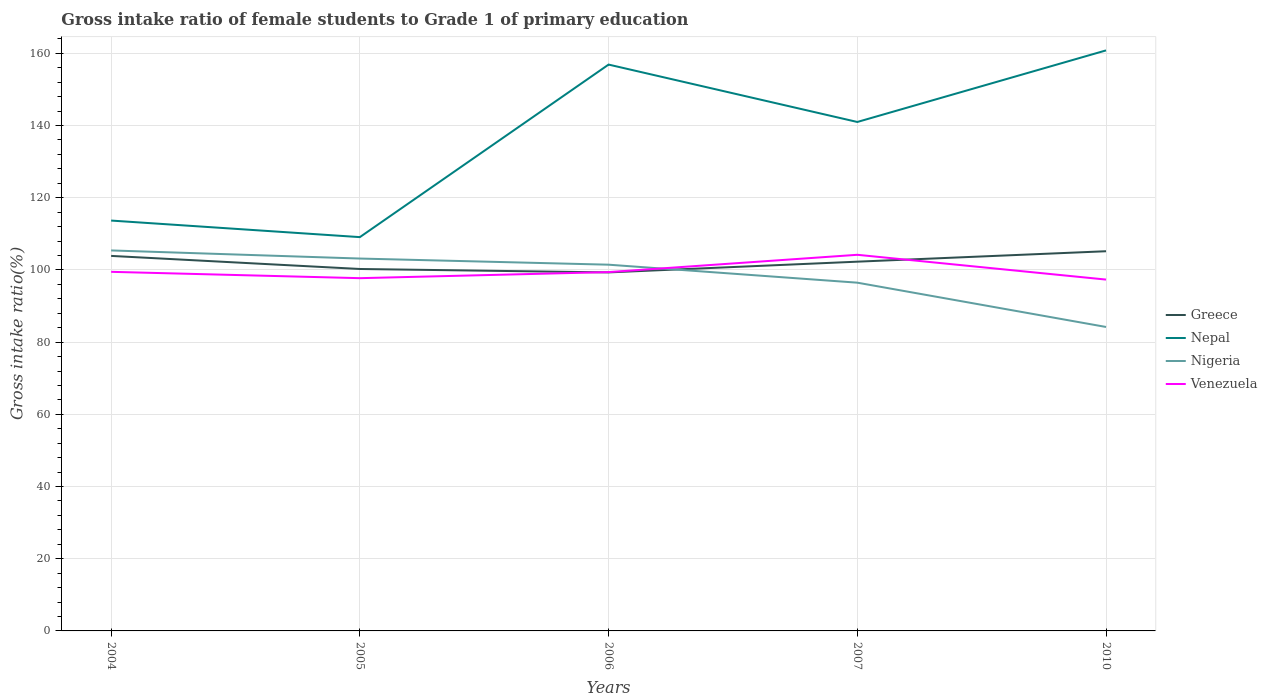Across all years, what is the maximum gross intake ratio in Nigeria?
Ensure brevity in your answer.  84.2. In which year was the gross intake ratio in Nepal maximum?
Give a very brief answer. 2005. What is the total gross intake ratio in Greece in the graph?
Keep it short and to the point. -5.87. What is the difference between the highest and the second highest gross intake ratio in Nigeria?
Your answer should be very brief. 21.2. What is the difference between the highest and the lowest gross intake ratio in Venezuela?
Your answer should be compact. 1. Is the gross intake ratio in Nepal strictly greater than the gross intake ratio in Venezuela over the years?
Provide a succinct answer. No. Does the graph contain grids?
Your answer should be very brief. Yes. How many legend labels are there?
Offer a terse response. 4. What is the title of the graph?
Keep it short and to the point. Gross intake ratio of female students to Grade 1 of primary education. Does "Kiribati" appear as one of the legend labels in the graph?
Ensure brevity in your answer.  No. What is the label or title of the X-axis?
Provide a short and direct response. Years. What is the label or title of the Y-axis?
Your response must be concise. Gross intake ratio(%). What is the Gross intake ratio(%) in Greece in 2004?
Provide a short and direct response. 103.89. What is the Gross intake ratio(%) of Nepal in 2004?
Your response must be concise. 113.68. What is the Gross intake ratio(%) in Nigeria in 2004?
Offer a terse response. 105.4. What is the Gross intake ratio(%) of Venezuela in 2004?
Your answer should be compact. 99.47. What is the Gross intake ratio(%) of Greece in 2005?
Ensure brevity in your answer.  100.26. What is the Gross intake ratio(%) in Nepal in 2005?
Provide a succinct answer. 109.09. What is the Gross intake ratio(%) of Nigeria in 2005?
Your response must be concise. 103.15. What is the Gross intake ratio(%) in Venezuela in 2005?
Keep it short and to the point. 97.72. What is the Gross intake ratio(%) of Greece in 2006?
Provide a succinct answer. 99.31. What is the Gross intake ratio(%) of Nepal in 2006?
Provide a succinct answer. 156.88. What is the Gross intake ratio(%) in Nigeria in 2006?
Offer a very short reply. 101.45. What is the Gross intake ratio(%) of Venezuela in 2006?
Ensure brevity in your answer.  99.4. What is the Gross intake ratio(%) of Greece in 2007?
Your response must be concise. 102.29. What is the Gross intake ratio(%) of Nepal in 2007?
Keep it short and to the point. 140.98. What is the Gross intake ratio(%) of Nigeria in 2007?
Offer a terse response. 96.47. What is the Gross intake ratio(%) in Venezuela in 2007?
Give a very brief answer. 104.19. What is the Gross intake ratio(%) of Greece in 2010?
Provide a short and direct response. 105.18. What is the Gross intake ratio(%) of Nepal in 2010?
Your answer should be very brief. 160.81. What is the Gross intake ratio(%) of Nigeria in 2010?
Offer a very short reply. 84.2. What is the Gross intake ratio(%) of Venezuela in 2010?
Offer a terse response. 97.33. Across all years, what is the maximum Gross intake ratio(%) of Greece?
Your answer should be very brief. 105.18. Across all years, what is the maximum Gross intake ratio(%) of Nepal?
Your answer should be compact. 160.81. Across all years, what is the maximum Gross intake ratio(%) of Nigeria?
Ensure brevity in your answer.  105.4. Across all years, what is the maximum Gross intake ratio(%) of Venezuela?
Your answer should be very brief. 104.19. Across all years, what is the minimum Gross intake ratio(%) of Greece?
Your response must be concise. 99.31. Across all years, what is the minimum Gross intake ratio(%) of Nepal?
Your answer should be very brief. 109.09. Across all years, what is the minimum Gross intake ratio(%) in Nigeria?
Offer a very short reply. 84.2. Across all years, what is the minimum Gross intake ratio(%) in Venezuela?
Your response must be concise. 97.33. What is the total Gross intake ratio(%) in Greece in the graph?
Your answer should be very brief. 510.92. What is the total Gross intake ratio(%) in Nepal in the graph?
Provide a short and direct response. 681.44. What is the total Gross intake ratio(%) in Nigeria in the graph?
Provide a short and direct response. 490.67. What is the total Gross intake ratio(%) in Venezuela in the graph?
Your answer should be very brief. 498.11. What is the difference between the Gross intake ratio(%) in Greece in 2004 and that in 2005?
Offer a terse response. 3.62. What is the difference between the Gross intake ratio(%) in Nepal in 2004 and that in 2005?
Your response must be concise. 4.59. What is the difference between the Gross intake ratio(%) of Nigeria in 2004 and that in 2005?
Keep it short and to the point. 2.25. What is the difference between the Gross intake ratio(%) in Venezuela in 2004 and that in 2005?
Your response must be concise. 1.76. What is the difference between the Gross intake ratio(%) in Greece in 2004 and that in 2006?
Give a very brief answer. 4.57. What is the difference between the Gross intake ratio(%) in Nepal in 2004 and that in 2006?
Make the answer very short. -43.21. What is the difference between the Gross intake ratio(%) of Nigeria in 2004 and that in 2006?
Ensure brevity in your answer.  3.94. What is the difference between the Gross intake ratio(%) in Venezuela in 2004 and that in 2006?
Your answer should be very brief. 0.07. What is the difference between the Gross intake ratio(%) in Greece in 2004 and that in 2007?
Your response must be concise. 1.6. What is the difference between the Gross intake ratio(%) of Nepal in 2004 and that in 2007?
Your answer should be compact. -27.31. What is the difference between the Gross intake ratio(%) of Nigeria in 2004 and that in 2007?
Your answer should be compact. 8.93. What is the difference between the Gross intake ratio(%) in Venezuela in 2004 and that in 2007?
Offer a very short reply. -4.72. What is the difference between the Gross intake ratio(%) in Greece in 2004 and that in 2010?
Keep it short and to the point. -1.29. What is the difference between the Gross intake ratio(%) in Nepal in 2004 and that in 2010?
Make the answer very short. -47.14. What is the difference between the Gross intake ratio(%) of Nigeria in 2004 and that in 2010?
Make the answer very short. 21.2. What is the difference between the Gross intake ratio(%) in Venezuela in 2004 and that in 2010?
Provide a short and direct response. 2.15. What is the difference between the Gross intake ratio(%) of Greece in 2005 and that in 2006?
Your answer should be compact. 0.95. What is the difference between the Gross intake ratio(%) in Nepal in 2005 and that in 2006?
Provide a short and direct response. -47.8. What is the difference between the Gross intake ratio(%) of Nigeria in 2005 and that in 2006?
Keep it short and to the point. 1.7. What is the difference between the Gross intake ratio(%) in Venezuela in 2005 and that in 2006?
Provide a short and direct response. -1.68. What is the difference between the Gross intake ratio(%) of Greece in 2005 and that in 2007?
Make the answer very short. -2.03. What is the difference between the Gross intake ratio(%) in Nepal in 2005 and that in 2007?
Give a very brief answer. -31.89. What is the difference between the Gross intake ratio(%) of Nigeria in 2005 and that in 2007?
Give a very brief answer. 6.68. What is the difference between the Gross intake ratio(%) of Venezuela in 2005 and that in 2007?
Provide a short and direct response. -6.48. What is the difference between the Gross intake ratio(%) of Greece in 2005 and that in 2010?
Provide a succinct answer. -4.92. What is the difference between the Gross intake ratio(%) of Nepal in 2005 and that in 2010?
Your response must be concise. -51.72. What is the difference between the Gross intake ratio(%) in Nigeria in 2005 and that in 2010?
Provide a short and direct response. 18.95. What is the difference between the Gross intake ratio(%) of Venezuela in 2005 and that in 2010?
Your response must be concise. 0.39. What is the difference between the Gross intake ratio(%) of Greece in 2006 and that in 2007?
Provide a succinct answer. -2.98. What is the difference between the Gross intake ratio(%) in Nepal in 2006 and that in 2007?
Ensure brevity in your answer.  15.9. What is the difference between the Gross intake ratio(%) in Nigeria in 2006 and that in 2007?
Your response must be concise. 4.98. What is the difference between the Gross intake ratio(%) in Venezuela in 2006 and that in 2007?
Give a very brief answer. -4.79. What is the difference between the Gross intake ratio(%) in Greece in 2006 and that in 2010?
Give a very brief answer. -5.87. What is the difference between the Gross intake ratio(%) of Nepal in 2006 and that in 2010?
Provide a short and direct response. -3.93. What is the difference between the Gross intake ratio(%) of Nigeria in 2006 and that in 2010?
Your answer should be compact. 17.25. What is the difference between the Gross intake ratio(%) in Venezuela in 2006 and that in 2010?
Provide a short and direct response. 2.08. What is the difference between the Gross intake ratio(%) in Greece in 2007 and that in 2010?
Offer a terse response. -2.89. What is the difference between the Gross intake ratio(%) in Nepal in 2007 and that in 2010?
Keep it short and to the point. -19.83. What is the difference between the Gross intake ratio(%) of Nigeria in 2007 and that in 2010?
Provide a short and direct response. 12.27. What is the difference between the Gross intake ratio(%) of Venezuela in 2007 and that in 2010?
Offer a very short reply. 6.87. What is the difference between the Gross intake ratio(%) in Greece in 2004 and the Gross intake ratio(%) in Nepal in 2005?
Make the answer very short. -5.2. What is the difference between the Gross intake ratio(%) of Greece in 2004 and the Gross intake ratio(%) of Nigeria in 2005?
Give a very brief answer. 0.73. What is the difference between the Gross intake ratio(%) in Greece in 2004 and the Gross intake ratio(%) in Venezuela in 2005?
Ensure brevity in your answer.  6.17. What is the difference between the Gross intake ratio(%) of Nepal in 2004 and the Gross intake ratio(%) of Nigeria in 2005?
Provide a succinct answer. 10.52. What is the difference between the Gross intake ratio(%) of Nepal in 2004 and the Gross intake ratio(%) of Venezuela in 2005?
Your response must be concise. 15.96. What is the difference between the Gross intake ratio(%) in Nigeria in 2004 and the Gross intake ratio(%) in Venezuela in 2005?
Make the answer very short. 7.68. What is the difference between the Gross intake ratio(%) of Greece in 2004 and the Gross intake ratio(%) of Nepal in 2006?
Offer a very short reply. -53. What is the difference between the Gross intake ratio(%) in Greece in 2004 and the Gross intake ratio(%) in Nigeria in 2006?
Provide a short and direct response. 2.43. What is the difference between the Gross intake ratio(%) in Greece in 2004 and the Gross intake ratio(%) in Venezuela in 2006?
Offer a very short reply. 4.48. What is the difference between the Gross intake ratio(%) in Nepal in 2004 and the Gross intake ratio(%) in Nigeria in 2006?
Your response must be concise. 12.22. What is the difference between the Gross intake ratio(%) in Nepal in 2004 and the Gross intake ratio(%) in Venezuela in 2006?
Offer a terse response. 14.27. What is the difference between the Gross intake ratio(%) of Nigeria in 2004 and the Gross intake ratio(%) of Venezuela in 2006?
Offer a very short reply. 6. What is the difference between the Gross intake ratio(%) of Greece in 2004 and the Gross intake ratio(%) of Nepal in 2007?
Provide a short and direct response. -37.1. What is the difference between the Gross intake ratio(%) in Greece in 2004 and the Gross intake ratio(%) in Nigeria in 2007?
Keep it short and to the point. 7.42. What is the difference between the Gross intake ratio(%) of Greece in 2004 and the Gross intake ratio(%) of Venezuela in 2007?
Offer a very short reply. -0.31. What is the difference between the Gross intake ratio(%) in Nepal in 2004 and the Gross intake ratio(%) in Nigeria in 2007?
Provide a succinct answer. 17.21. What is the difference between the Gross intake ratio(%) in Nepal in 2004 and the Gross intake ratio(%) in Venezuela in 2007?
Ensure brevity in your answer.  9.48. What is the difference between the Gross intake ratio(%) of Nigeria in 2004 and the Gross intake ratio(%) of Venezuela in 2007?
Your response must be concise. 1.2. What is the difference between the Gross intake ratio(%) in Greece in 2004 and the Gross intake ratio(%) in Nepal in 2010?
Make the answer very short. -56.93. What is the difference between the Gross intake ratio(%) of Greece in 2004 and the Gross intake ratio(%) of Nigeria in 2010?
Your answer should be compact. 19.69. What is the difference between the Gross intake ratio(%) in Greece in 2004 and the Gross intake ratio(%) in Venezuela in 2010?
Provide a short and direct response. 6.56. What is the difference between the Gross intake ratio(%) in Nepal in 2004 and the Gross intake ratio(%) in Nigeria in 2010?
Provide a succinct answer. 29.48. What is the difference between the Gross intake ratio(%) of Nepal in 2004 and the Gross intake ratio(%) of Venezuela in 2010?
Keep it short and to the point. 16.35. What is the difference between the Gross intake ratio(%) of Nigeria in 2004 and the Gross intake ratio(%) of Venezuela in 2010?
Your answer should be compact. 8.07. What is the difference between the Gross intake ratio(%) in Greece in 2005 and the Gross intake ratio(%) in Nepal in 2006?
Your response must be concise. -56.62. What is the difference between the Gross intake ratio(%) in Greece in 2005 and the Gross intake ratio(%) in Nigeria in 2006?
Ensure brevity in your answer.  -1.19. What is the difference between the Gross intake ratio(%) in Greece in 2005 and the Gross intake ratio(%) in Venezuela in 2006?
Provide a succinct answer. 0.86. What is the difference between the Gross intake ratio(%) in Nepal in 2005 and the Gross intake ratio(%) in Nigeria in 2006?
Offer a terse response. 7.64. What is the difference between the Gross intake ratio(%) of Nepal in 2005 and the Gross intake ratio(%) of Venezuela in 2006?
Provide a short and direct response. 9.69. What is the difference between the Gross intake ratio(%) of Nigeria in 2005 and the Gross intake ratio(%) of Venezuela in 2006?
Make the answer very short. 3.75. What is the difference between the Gross intake ratio(%) of Greece in 2005 and the Gross intake ratio(%) of Nepal in 2007?
Keep it short and to the point. -40.72. What is the difference between the Gross intake ratio(%) of Greece in 2005 and the Gross intake ratio(%) of Nigeria in 2007?
Provide a succinct answer. 3.79. What is the difference between the Gross intake ratio(%) in Greece in 2005 and the Gross intake ratio(%) in Venezuela in 2007?
Your response must be concise. -3.93. What is the difference between the Gross intake ratio(%) of Nepal in 2005 and the Gross intake ratio(%) of Nigeria in 2007?
Offer a very short reply. 12.62. What is the difference between the Gross intake ratio(%) in Nepal in 2005 and the Gross intake ratio(%) in Venezuela in 2007?
Your response must be concise. 4.9. What is the difference between the Gross intake ratio(%) in Nigeria in 2005 and the Gross intake ratio(%) in Venezuela in 2007?
Offer a very short reply. -1.04. What is the difference between the Gross intake ratio(%) of Greece in 2005 and the Gross intake ratio(%) of Nepal in 2010?
Offer a very short reply. -60.55. What is the difference between the Gross intake ratio(%) in Greece in 2005 and the Gross intake ratio(%) in Nigeria in 2010?
Provide a short and direct response. 16.06. What is the difference between the Gross intake ratio(%) in Greece in 2005 and the Gross intake ratio(%) in Venezuela in 2010?
Provide a succinct answer. 2.93. What is the difference between the Gross intake ratio(%) in Nepal in 2005 and the Gross intake ratio(%) in Nigeria in 2010?
Give a very brief answer. 24.89. What is the difference between the Gross intake ratio(%) of Nepal in 2005 and the Gross intake ratio(%) of Venezuela in 2010?
Provide a succinct answer. 11.76. What is the difference between the Gross intake ratio(%) of Nigeria in 2005 and the Gross intake ratio(%) of Venezuela in 2010?
Your response must be concise. 5.83. What is the difference between the Gross intake ratio(%) in Greece in 2006 and the Gross intake ratio(%) in Nepal in 2007?
Provide a short and direct response. -41.67. What is the difference between the Gross intake ratio(%) of Greece in 2006 and the Gross intake ratio(%) of Nigeria in 2007?
Provide a succinct answer. 2.84. What is the difference between the Gross intake ratio(%) in Greece in 2006 and the Gross intake ratio(%) in Venezuela in 2007?
Make the answer very short. -4.88. What is the difference between the Gross intake ratio(%) of Nepal in 2006 and the Gross intake ratio(%) of Nigeria in 2007?
Your answer should be compact. 60.42. What is the difference between the Gross intake ratio(%) of Nepal in 2006 and the Gross intake ratio(%) of Venezuela in 2007?
Your answer should be compact. 52.69. What is the difference between the Gross intake ratio(%) of Nigeria in 2006 and the Gross intake ratio(%) of Venezuela in 2007?
Ensure brevity in your answer.  -2.74. What is the difference between the Gross intake ratio(%) in Greece in 2006 and the Gross intake ratio(%) in Nepal in 2010?
Keep it short and to the point. -61.5. What is the difference between the Gross intake ratio(%) of Greece in 2006 and the Gross intake ratio(%) of Nigeria in 2010?
Your answer should be compact. 15.11. What is the difference between the Gross intake ratio(%) of Greece in 2006 and the Gross intake ratio(%) of Venezuela in 2010?
Give a very brief answer. 1.99. What is the difference between the Gross intake ratio(%) of Nepal in 2006 and the Gross intake ratio(%) of Nigeria in 2010?
Make the answer very short. 72.69. What is the difference between the Gross intake ratio(%) of Nepal in 2006 and the Gross intake ratio(%) of Venezuela in 2010?
Provide a short and direct response. 59.56. What is the difference between the Gross intake ratio(%) in Nigeria in 2006 and the Gross intake ratio(%) in Venezuela in 2010?
Keep it short and to the point. 4.13. What is the difference between the Gross intake ratio(%) of Greece in 2007 and the Gross intake ratio(%) of Nepal in 2010?
Make the answer very short. -58.52. What is the difference between the Gross intake ratio(%) in Greece in 2007 and the Gross intake ratio(%) in Nigeria in 2010?
Provide a succinct answer. 18.09. What is the difference between the Gross intake ratio(%) of Greece in 2007 and the Gross intake ratio(%) of Venezuela in 2010?
Your answer should be very brief. 4.96. What is the difference between the Gross intake ratio(%) in Nepal in 2007 and the Gross intake ratio(%) in Nigeria in 2010?
Make the answer very short. 56.79. What is the difference between the Gross intake ratio(%) of Nepal in 2007 and the Gross intake ratio(%) of Venezuela in 2010?
Make the answer very short. 43.66. What is the difference between the Gross intake ratio(%) in Nigeria in 2007 and the Gross intake ratio(%) in Venezuela in 2010?
Your answer should be very brief. -0.86. What is the average Gross intake ratio(%) in Greece per year?
Offer a terse response. 102.18. What is the average Gross intake ratio(%) of Nepal per year?
Your answer should be very brief. 136.29. What is the average Gross intake ratio(%) of Nigeria per year?
Your answer should be very brief. 98.13. What is the average Gross intake ratio(%) of Venezuela per year?
Make the answer very short. 99.62. In the year 2004, what is the difference between the Gross intake ratio(%) in Greece and Gross intake ratio(%) in Nepal?
Give a very brief answer. -9.79. In the year 2004, what is the difference between the Gross intake ratio(%) in Greece and Gross intake ratio(%) in Nigeria?
Give a very brief answer. -1.51. In the year 2004, what is the difference between the Gross intake ratio(%) in Greece and Gross intake ratio(%) in Venezuela?
Offer a terse response. 4.41. In the year 2004, what is the difference between the Gross intake ratio(%) in Nepal and Gross intake ratio(%) in Nigeria?
Your answer should be compact. 8.28. In the year 2004, what is the difference between the Gross intake ratio(%) in Nepal and Gross intake ratio(%) in Venezuela?
Ensure brevity in your answer.  14.2. In the year 2004, what is the difference between the Gross intake ratio(%) in Nigeria and Gross intake ratio(%) in Venezuela?
Make the answer very short. 5.92. In the year 2005, what is the difference between the Gross intake ratio(%) in Greece and Gross intake ratio(%) in Nepal?
Offer a very short reply. -8.83. In the year 2005, what is the difference between the Gross intake ratio(%) of Greece and Gross intake ratio(%) of Nigeria?
Give a very brief answer. -2.89. In the year 2005, what is the difference between the Gross intake ratio(%) in Greece and Gross intake ratio(%) in Venezuela?
Provide a succinct answer. 2.54. In the year 2005, what is the difference between the Gross intake ratio(%) in Nepal and Gross intake ratio(%) in Nigeria?
Provide a succinct answer. 5.94. In the year 2005, what is the difference between the Gross intake ratio(%) in Nepal and Gross intake ratio(%) in Venezuela?
Provide a short and direct response. 11.37. In the year 2005, what is the difference between the Gross intake ratio(%) of Nigeria and Gross intake ratio(%) of Venezuela?
Your response must be concise. 5.44. In the year 2006, what is the difference between the Gross intake ratio(%) in Greece and Gross intake ratio(%) in Nepal?
Your answer should be very brief. -57.57. In the year 2006, what is the difference between the Gross intake ratio(%) of Greece and Gross intake ratio(%) of Nigeria?
Ensure brevity in your answer.  -2.14. In the year 2006, what is the difference between the Gross intake ratio(%) in Greece and Gross intake ratio(%) in Venezuela?
Offer a very short reply. -0.09. In the year 2006, what is the difference between the Gross intake ratio(%) of Nepal and Gross intake ratio(%) of Nigeria?
Your response must be concise. 55.43. In the year 2006, what is the difference between the Gross intake ratio(%) of Nepal and Gross intake ratio(%) of Venezuela?
Provide a short and direct response. 57.48. In the year 2006, what is the difference between the Gross intake ratio(%) of Nigeria and Gross intake ratio(%) of Venezuela?
Offer a terse response. 2.05. In the year 2007, what is the difference between the Gross intake ratio(%) in Greece and Gross intake ratio(%) in Nepal?
Offer a very short reply. -38.69. In the year 2007, what is the difference between the Gross intake ratio(%) in Greece and Gross intake ratio(%) in Nigeria?
Offer a very short reply. 5.82. In the year 2007, what is the difference between the Gross intake ratio(%) in Greece and Gross intake ratio(%) in Venezuela?
Make the answer very short. -1.9. In the year 2007, what is the difference between the Gross intake ratio(%) in Nepal and Gross intake ratio(%) in Nigeria?
Ensure brevity in your answer.  44.51. In the year 2007, what is the difference between the Gross intake ratio(%) in Nepal and Gross intake ratio(%) in Venezuela?
Provide a succinct answer. 36.79. In the year 2007, what is the difference between the Gross intake ratio(%) of Nigeria and Gross intake ratio(%) of Venezuela?
Your answer should be very brief. -7.72. In the year 2010, what is the difference between the Gross intake ratio(%) of Greece and Gross intake ratio(%) of Nepal?
Offer a terse response. -55.63. In the year 2010, what is the difference between the Gross intake ratio(%) in Greece and Gross intake ratio(%) in Nigeria?
Ensure brevity in your answer.  20.98. In the year 2010, what is the difference between the Gross intake ratio(%) in Greece and Gross intake ratio(%) in Venezuela?
Give a very brief answer. 7.85. In the year 2010, what is the difference between the Gross intake ratio(%) of Nepal and Gross intake ratio(%) of Nigeria?
Offer a very short reply. 76.61. In the year 2010, what is the difference between the Gross intake ratio(%) of Nepal and Gross intake ratio(%) of Venezuela?
Provide a short and direct response. 63.48. In the year 2010, what is the difference between the Gross intake ratio(%) in Nigeria and Gross intake ratio(%) in Venezuela?
Provide a succinct answer. -13.13. What is the ratio of the Gross intake ratio(%) of Greece in 2004 to that in 2005?
Your answer should be very brief. 1.04. What is the ratio of the Gross intake ratio(%) of Nepal in 2004 to that in 2005?
Offer a terse response. 1.04. What is the ratio of the Gross intake ratio(%) in Nigeria in 2004 to that in 2005?
Keep it short and to the point. 1.02. What is the ratio of the Gross intake ratio(%) of Greece in 2004 to that in 2006?
Offer a terse response. 1.05. What is the ratio of the Gross intake ratio(%) in Nepal in 2004 to that in 2006?
Give a very brief answer. 0.72. What is the ratio of the Gross intake ratio(%) of Nigeria in 2004 to that in 2006?
Provide a succinct answer. 1.04. What is the ratio of the Gross intake ratio(%) in Venezuela in 2004 to that in 2006?
Your response must be concise. 1. What is the ratio of the Gross intake ratio(%) in Greece in 2004 to that in 2007?
Your answer should be very brief. 1.02. What is the ratio of the Gross intake ratio(%) in Nepal in 2004 to that in 2007?
Keep it short and to the point. 0.81. What is the ratio of the Gross intake ratio(%) of Nigeria in 2004 to that in 2007?
Give a very brief answer. 1.09. What is the ratio of the Gross intake ratio(%) of Venezuela in 2004 to that in 2007?
Your answer should be very brief. 0.95. What is the ratio of the Gross intake ratio(%) in Greece in 2004 to that in 2010?
Make the answer very short. 0.99. What is the ratio of the Gross intake ratio(%) of Nepal in 2004 to that in 2010?
Provide a short and direct response. 0.71. What is the ratio of the Gross intake ratio(%) in Nigeria in 2004 to that in 2010?
Offer a terse response. 1.25. What is the ratio of the Gross intake ratio(%) in Venezuela in 2004 to that in 2010?
Offer a terse response. 1.02. What is the ratio of the Gross intake ratio(%) in Greece in 2005 to that in 2006?
Offer a very short reply. 1.01. What is the ratio of the Gross intake ratio(%) of Nepal in 2005 to that in 2006?
Give a very brief answer. 0.7. What is the ratio of the Gross intake ratio(%) of Nigeria in 2005 to that in 2006?
Your answer should be compact. 1.02. What is the ratio of the Gross intake ratio(%) of Venezuela in 2005 to that in 2006?
Make the answer very short. 0.98. What is the ratio of the Gross intake ratio(%) of Greece in 2005 to that in 2007?
Your answer should be very brief. 0.98. What is the ratio of the Gross intake ratio(%) in Nepal in 2005 to that in 2007?
Make the answer very short. 0.77. What is the ratio of the Gross intake ratio(%) of Nigeria in 2005 to that in 2007?
Keep it short and to the point. 1.07. What is the ratio of the Gross intake ratio(%) of Venezuela in 2005 to that in 2007?
Offer a very short reply. 0.94. What is the ratio of the Gross intake ratio(%) in Greece in 2005 to that in 2010?
Your answer should be compact. 0.95. What is the ratio of the Gross intake ratio(%) of Nepal in 2005 to that in 2010?
Your response must be concise. 0.68. What is the ratio of the Gross intake ratio(%) of Nigeria in 2005 to that in 2010?
Make the answer very short. 1.23. What is the ratio of the Gross intake ratio(%) of Venezuela in 2005 to that in 2010?
Your answer should be compact. 1. What is the ratio of the Gross intake ratio(%) of Greece in 2006 to that in 2007?
Ensure brevity in your answer.  0.97. What is the ratio of the Gross intake ratio(%) in Nepal in 2006 to that in 2007?
Make the answer very short. 1.11. What is the ratio of the Gross intake ratio(%) of Nigeria in 2006 to that in 2007?
Offer a terse response. 1.05. What is the ratio of the Gross intake ratio(%) in Venezuela in 2006 to that in 2007?
Give a very brief answer. 0.95. What is the ratio of the Gross intake ratio(%) of Greece in 2006 to that in 2010?
Your answer should be very brief. 0.94. What is the ratio of the Gross intake ratio(%) in Nepal in 2006 to that in 2010?
Keep it short and to the point. 0.98. What is the ratio of the Gross intake ratio(%) in Nigeria in 2006 to that in 2010?
Your answer should be very brief. 1.2. What is the ratio of the Gross intake ratio(%) in Venezuela in 2006 to that in 2010?
Your answer should be very brief. 1.02. What is the ratio of the Gross intake ratio(%) of Greece in 2007 to that in 2010?
Give a very brief answer. 0.97. What is the ratio of the Gross intake ratio(%) of Nepal in 2007 to that in 2010?
Ensure brevity in your answer.  0.88. What is the ratio of the Gross intake ratio(%) of Nigeria in 2007 to that in 2010?
Provide a short and direct response. 1.15. What is the ratio of the Gross intake ratio(%) in Venezuela in 2007 to that in 2010?
Offer a very short reply. 1.07. What is the difference between the highest and the second highest Gross intake ratio(%) in Greece?
Ensure brevity in your answer.  1.29. What is the difference between the highest and the second highest Gross intake ratio(%) in Nepal?
Keep it short and to the point. 3.93. What is the difference between the highest and the second highest Gross intake ratio(%) in Nigeria?
Your answer should be compact. 2.25. What is the difference between the highest and the second highest Gross intake ratio(%) in Venezuela?
Your response must be concise. 4.72. What is the difference between the highest and the lowest Gross intake ratio(%) in Greece?
Ensure brevity in your answer.  5.87. What is the difference between the highest and the lowest Gross intake ratio(%) of Nepal?
Give a very brief answer. 51.72. What is the difference between the highest and the lowest Gross intake ratio(%) of Nigeria?
Provide a succinct answer. 21.2. What is the difference between the highest and the lowest Gross intake ratio(%) in Venezuela?
Give a very brief answer. 6.87. 